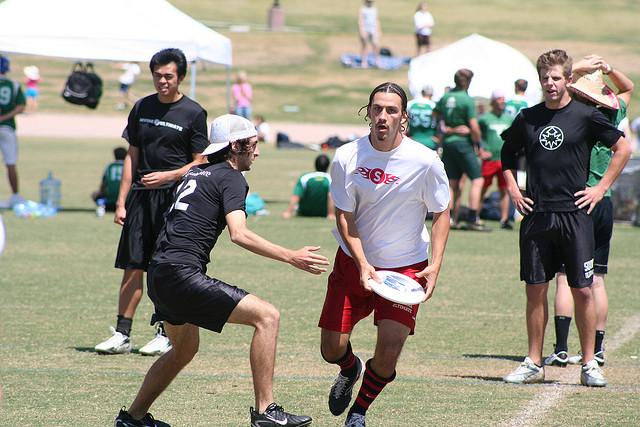Is there a game going on?
Be succinct. Yes. What color shorts does the man with the frisbee have on?
Concise answer only. Red. How many of these Frisbee players are wearing hats?
Quick response, please. 2. Are the players male or female?
Be succinct. Male. 